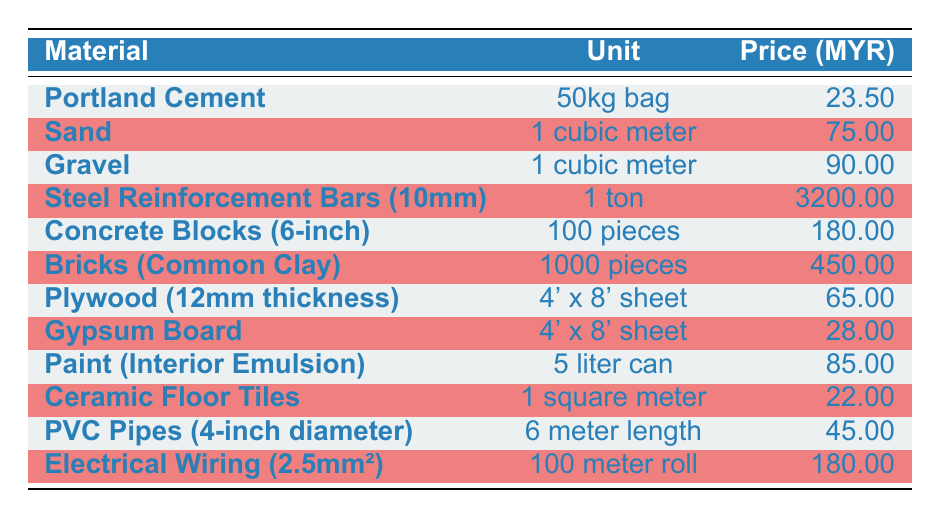What is the price of Portland Cement? The table lists Portland Cement's price under the "Price (MYR)" column. Referring to the corresponding row for Portland Cement, the price is 23.50 MYR.
Answer: 23.50 MYR What is the price of 1 cubic meter of Sand? The "Price (MYR)" column shows the value for Sand under its corresponding row. The price is 75.00 MYR for 1 cubic meter of Sand.
Answer: 75.00 MYR How much does 1000 pieces of Bricks (Common Clay) cost? The table indicates that the cost for 1000 pieces of Bricks (Common Clay) is listed in the "Price (MYR)" column. This amount is 450.00 MYR.
Answer: 450.00 MYR What is the total cost of 1 ton of Steel Reinforcement Bars and 100 pieces of Concrete Blocks? The price of 1 ton of Steel Reinforcement Bars is 3200.00 MYR and the price for 100 pieces of Concrete Blocks is 180.00 MYR. Adding these two amounts gives us 3200.00 + 180.00 = 3380.00 MYR.
Answer: 3380.00 MYR Is the price of 4' x 8' sheet of Gypsum Board less than the price of 4' x 8' sheet of Plywood? The price of Gypsum Board is 28.00 MYR and the price of Plywood is 65.00 MYR. Since 28.00 is less than 65.00, the statement is true.
Answer: Yes What is the difference in price between 1 square meter of Ceramic Floor Tiles and 6 meter length of PVC Pipes? The price for 1 square meter of Ceramic Floor Tiles is 22.00 MYR, and the price for 6 meter length of PVC Pipes is 45.00 MYR. The difference is calculated by subtracting: 45.00 - 22.00 = 23.00 MYR.
Answer: 23.00 MYR What is the average price of all construction materials listed? To calculate the average price, we first sum all the prices: 23.50 + 75.00 + 90.00 + 3200.00 + 180.00 + 450.00 + 65.00 + 28.00 + 85.00 + 22.00 + 45.00 + 180.00 = 4218.50 MYR. Then, since there are 12 materials, we divide by 12: 4218.50 / 12 = 351.54 MYR.
Answer: 351.54 MYR How many materials cost more than 100 MYR? To determine the number of materials costing more than 100 MYR, we look at the "Price (MYR)" column. The materials exceeding 100 MYR are Steel Reinforcement Bars (3200.00 MYR), Bricks (450.00 MYR), which amounts to 2 materials.
Answer: 2 Is the price of Electrical Wiring more than 180 MYR? The price of Electrical Wiring (2.5mm²) is listed as 180.00 MYR. Since it is equal and not more than 180 MYR, the statement is false.
Answer: No 